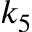Convert formula to latex. <formula><loc_0><loc_0><loc_500><loc_500>k _ { 5 }</formula> 